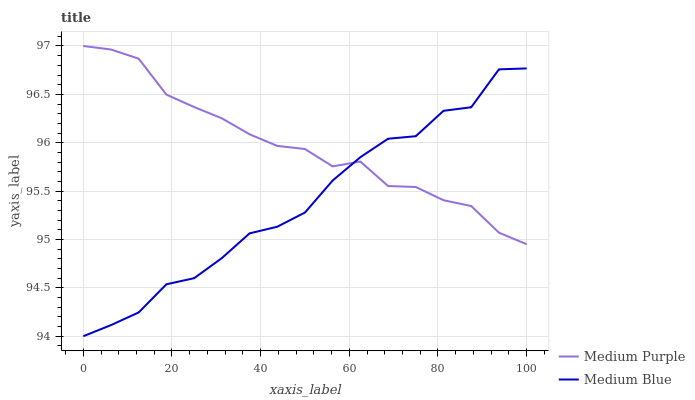Does Medium Blue have the minimum area under the curve?
Answer yes or no. Yes. Does Medium Purple have the maximum area under the curve?
Answer yes or no. Yes. Does Medium Blue have the maximum area under the curve?
Answer yes or no. No. Is Medium Purple the smoothest?
Answer yes or no. Yes. Is Medium Blue the roughest?
Answer yes or no. Yes. Is Medium Blue the smoothest?
Answer yes or no. No. Does Medium Blue have the lowest value?
Answer yes or no. Yes. Does Medium Purple have the highest value?
Answer yes or no. Yes. Does Medium Blue have the highest value?
Answer yes or no. No. Does Medium Purple intersect Medium Blue?
Answer yes or no. Yes. Is Medium Purple less than Medium Blue?
Answer yes or no. No. Is Medium Purple greater than Medium Blue?
Answer yes or no. No. 